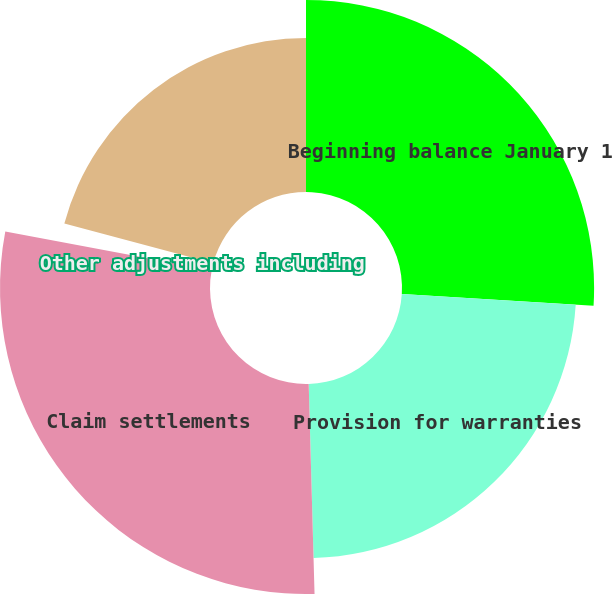<chart> <loc_0><loc_0><loc_500><loc_500><pie_chart><fcel>Beginning balance January 1<fcel>Provision for warranties<fcel>Claim settlements<fcel>Other adjustments including<fcel>Ending balance December 31<nl><fcel>25.99%<fcel>23.57%<fcel>28.41%<fcel>1.19%<fcel>20.85%<nl></chart> 